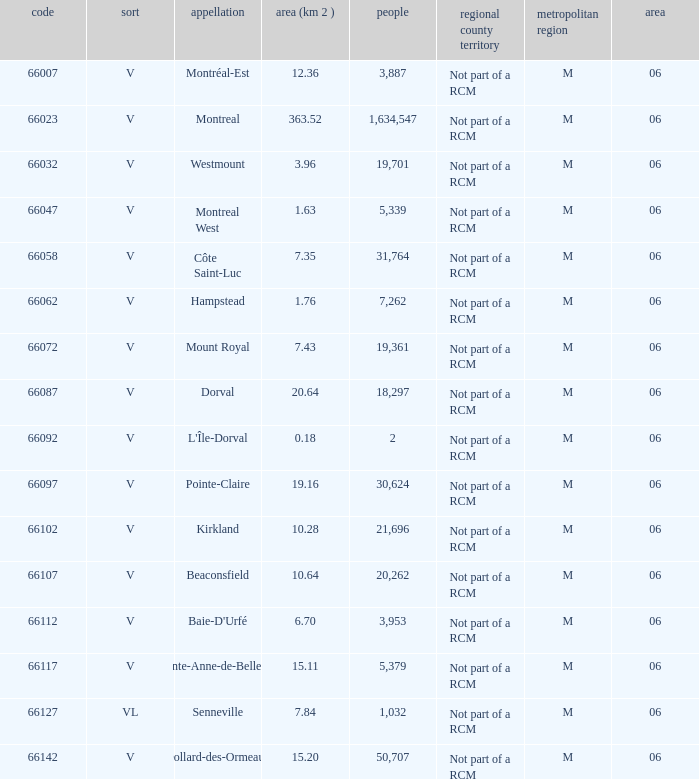What is the largest area with a Code of 66097, and a Region larger than 6? None. 